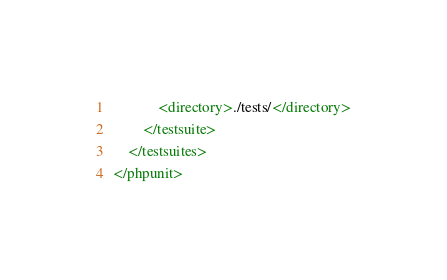<code> <loc_0><loc_0><loc_500><loc_500><_XML_>            <directory>./tests/</directory>
        </testsuite>
    </testsuites>
</phpunit>
</code> 